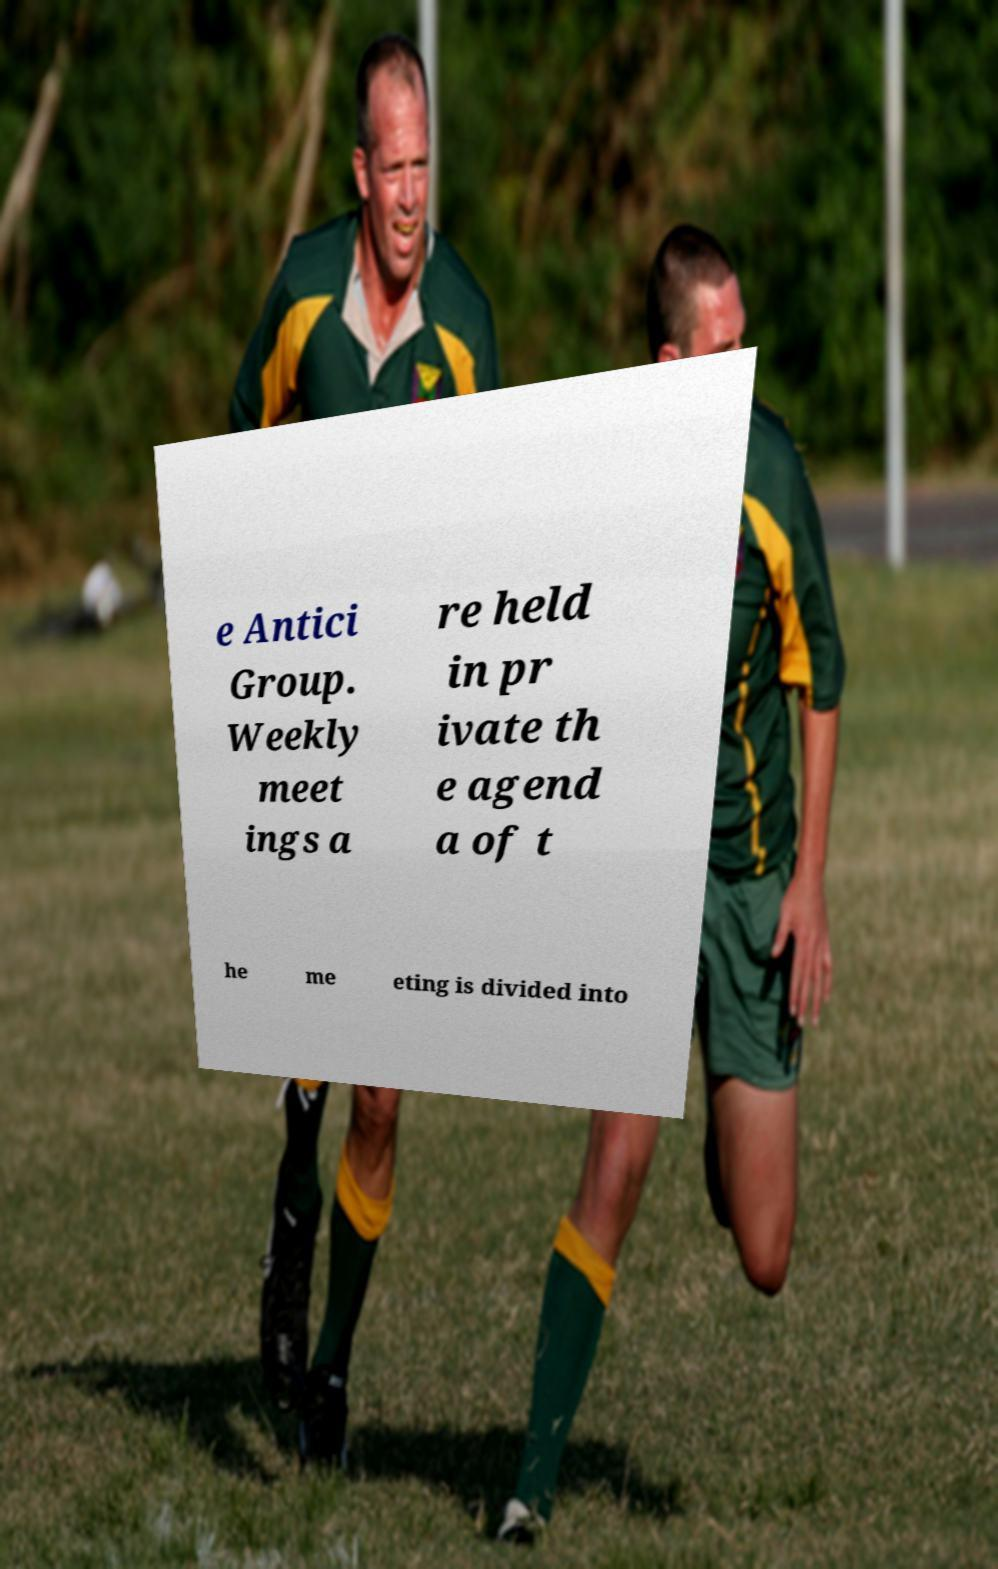What messages or text are displayed in this image? I need them in a readable, typed format. e Antici Group. Weekly meet ings a re held in pr ivate th e agend a of t he me eting is divided into 